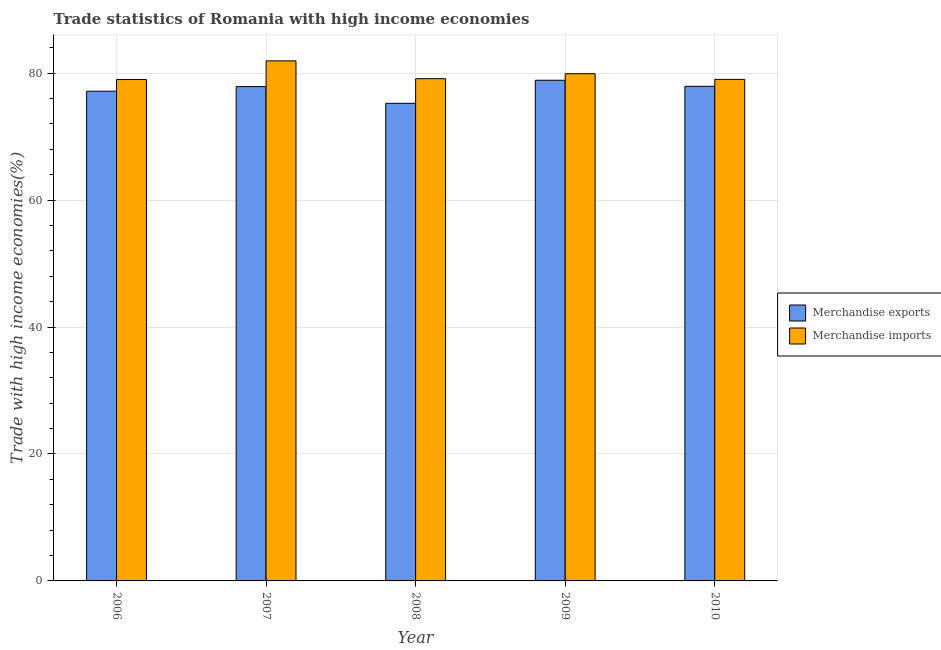How many different coloured bars are there?
Give a very brief answer. 2. Are the number of bars on each tick of the X-axis equal?
Keep it short and to the point. Yes. What is the merchandise imports in 2006?
Your answer should be compact. 79. Across all years, what is the maximum merchandise imports?
Make the answer very short. 81.93. Across all years, what is the minimum merchandise exports?
Make the answer very short. 75.24. In which year was the merchandise exports minimum?
Ensure brevity in your answer.  2008. What is the total merchandise imports in the graph?
Give a very brief answer. 398.97. What is the difference between the merchandise exports in 2008 and that in 2010?
Your answer should be very brief. -2.68. What is the difference between the merchandise exports in 2008 and the merchandise imports in 2007?
Your response must be concise. -2.63. What is the average merchandise exports per year?
Your answer should be compact. 77.41. What is the ratio of the merchandise exports in 2008 to that in 2010?
Offer a terse response. 0.97. Is the difference between the merchandise imports in 2008 and 2009 greater than the difference between the merchandise exports in 2008 and 2009?
Offer a terse response. No. What is the difference between the highest and the second highest merchandise exports?
Ensure brevity in your answer.  0.95. What is the difference between the highest and the lowest merchandise exports?
Your answer should be very brief. 3.63. Is the sum of the merchandise imports in 2006 and 2010 greater than the maximum merchandise exports across all years?
Offer a very short reply. Yes. What does the 2nd bar from the right in 2008 represents?
Make the answer very short. Merchandise exports. How many bars are there?
Offer a terse response. 10. Are all the bars in the graph horizontal?
Your response must be concise. No. What is the difference between two consecutive major ticks on the Y-axis?
Provide a succinct answer. 20. Are the values on the major ticks of Y-axis written in scientific E-notation?
Make the answer very short. No. Does the graph contain any zero values?
Your answer should be very brief. No. How are the legend labels stacked?
Your response must be concise. Vertical. What is the title of the graph?
Offer a very short reply. Trade statistics of Romania with high income economies. Does "Imports" appear as one of the legend labels in the graph?
Make the answer very short. No. What is the label or title of the Y-axis?
Make the answer very short. Trade with high income economies(%). What is the Trade with high income economies(%) in Merchandise exports in 2006?
Make the answer very short. 77.15. What is the Trade with high income economies(%) in Merchandise imports in 2006?
Your answer should be compact. 79. What is the Trade with high income economies(%) in Merchandise exports in 2007?
Your response must be concise. 77.88. What is the Trade with high income economies(%) of Merchandise imports in 2007?
Give a very brief answer. 81.93. What is the Trade with high income economies(%) in Merchandise exports in 2008?
Give a very brief answer. 75.24. What is the Trade with high income economies(%) of Merchandise imports in 2008?
Your answer should be compact. 79.12. What is the Trade with high income economies(%) in Merchandise exports in 2009?
Your response must be concise. 78.87. What is the Trade with high income economies(%) of Merchandise imports in 2009?
Provide a short and direct response. 79.91. What is the Trade with high income economies(%) in Merchandise exports in 2010?
Offer a very short reply. 77.92. What is the Trade with high income economies(%) of Merchandise imports in 2010?
Provide a short and direct response. 79.01. Across all years, what is the maximum Trade with high income economies(%) of Merchandise exports?
Provide a succinct answer. 78.87. Across all years, what is the maximum Trade with high income economies(%) in Merchandise imports?
Keep it short and to the point. 81.93. Across all years, what is the minimum Trade with high income economies(%) in Merchandise exports?
Your answer should be very brief. 75.24. Across all years, what is the minimum Trade with high income economies(%) of Merchandise imports?
Your response must be concise. 79. What is the total Trade with high income economies(%) in Merchandise exports in the graph?
Provide a succinct answer. 387.06. What is the total Trade with high income economies(%) of Merchandise imports in the graph?
Keep it short and to the point. 398.97. What is the difference between the Trade with high income economies(%) of Merchandise exports in 2006 and that in 2007?
Keep it short and to the point. -0.73. What is the difference between the Trade with high income economies(%) of Merchandise imports in 2006 and that in 2007?
Offer a very short reply. -2.93. What is the difference between the Trade with high income economies(%) in Merchandise exports in 2006 and that in 2008?
Offer a very short reply. 1.91. What is the difference between the Trade with high income economies(%) of Merchandise imports in 2006 and that in 2008?
Your answer should be very brief. -0.13. What is the difference between the Trade with high income economies(%) in Merchandise exports in 2006 and that in 2009?
Make the answer very short. -1.72. What is the difference between the Trade with high income economies(%) of Merchandise imports in 2006 and that in 2009?
Your answer should be very brief. -0.91. What is the difference between the Trade with high income economies(%) of Merchandise exports in 2006 and that in 2010?
Your answer should be very brief. -0.77. What is the difference between the Trade with high income economies(%) in Merchandise imports in 2006 and that in 2010?
Provide a succinct answer. -0.02. What is the difference between the Trade with high income economies(%) of Merchandise exports in 2007 and that in 2008?
Make the answer very short. 2.63. What is the difference between the Trade with high income economies(%) of Merchandise imports in 2007 and that in 2008?
Offer a terse response. 2.8. What is the difference between the Trade with high income economies(%) in Merchandise exports in 2007 and that in 2009?
Provide a succinct answer. -1. What is the difference between the Trade with high income economies(%) in Merchandise imports in 2007 and that in 2009?
Keep it short and to the point. 2.02. What is the difference between the Trade with high income economies(%) in Merchandise exports in 2007 and that in 2010?
Provide a succinct answer. -0.04. What is the difference between the Trade with high income economies(%) of Merchandise imports in 2007 and that in 2010?
Provide a succinct answer. 2.91. What is the difference between the Trade with high income economies(%) of Merchandise exports in 2008 and that in 2009?
Offer a very short reply. -3.63. What is the difference between the Trade with high income economies(%) of Merchandise imports in 2008 and that in 2009?
Make the answer very short. -0.78. What is the difference between the Trade with high income economies(%) in Merchandise exports in 2008 and that in 2010?
Provide a succinct answer. -2.68. What is the difference between the Trade with high income economies(%) in Merchandise imports in 2008 and that in 2010?
Make the answer very short. 0.11. What is the difference between the Trade with high income economies(%) in Merchandise exports in 2009 and that in 2010?
Offer a terse response. 0.95. What is the difference between the Trade with high income economies(%) in Merchandise imports in 2009 and that in 2010?
Your response must be concise. 0.89. What is the difference between the Trade with high income economies(%) of Merchandise exports in 2006 and the Trade with high income economies(%) of Merchandise imports in 2007?
Provide a short and direct response. -4.78. What is the difference between the Trade with high income economies(%) in Merchandise exports in 2006 and the Trade with high income economies(%) in Merchandise imports in 2008?
Your answer should be very brief. -1.97. What is the difference between the Trade with high income economies(%) of Merchandise exports in 2006 and the Trade with high income economies(%) of Merchandise imports in 2009?
Ensure brevity in your answer.  -2.76. What is the difference between the Trade with high income economies(%) in Merchandise exports in 2006 and the Trade with high income economies(%) in Merchandise imports in 2010?
Offer a very short reply. -1.86. What is the difference between the Trade with high income economies(%) of Merchandise exports in 2007 and the Trade with high income economies(%) of Merchandise imports in 2008?
Offer a terse response. -1.25. What is the difference between the Trade with high income economies(%) in Merchandise exports in 2007 and the Trade with high income economies(%) in Merchandise imports in 2009?
Your response must be concise. -2.03. What is the difference between the Trade with high income economies(%) in Merchandise exports in 2007 and the Trade with high income economies(%) in Merchandise imports in 2010?
Provide a succinct answer. -1.14. What is the difference between the Trade with high income economies(%) of Merchandise exports in 2008 and the Trade with high income economies(%) of Merchandise imports in 2009?
Provide a short and direct response. -4.66. What is the difference between the Trade with high income economies(%) of Merchandise exports in 2008 and the Trade with high income economies(%) of Merchandise imports in 2010?
Make the answer very short. -3.77. What is the difference between the Trade with high income economies(%) in Merchandise exports in 2009 and the Trade with high income economies(%) in Merchandise imports in 2010?
Give a very brief answer. -0.14. What is the average Trade with high income economies(%) in Merchandise exports per year?
Make the answer very short. 77.41. What is the average Trade with high income economies(%) of Merchandise imports per year?
Provide a succinct answer. 79.79. In the year 2006, what is the difference between the Trade with high income economies(%) in Merchandise exports and Trade with high income economies(%) in Merchandise imports?
Give a very brief answer. -1.85. In the year 2007, what is the difference between the Trade with high income economies(%) of Merchandise exports and Trade with high income economies(%) of Merchandise imports?
Make the answer very short. -4.05. In the year 2008, what is the difference between the Trade with high income economies(%) of Merchandise exports and Trade with high income economies(%) of Merchandise imports?
Your response must be concise. -3.88. In the year 2009, what is the difference between the Trade with high income economies(%) of Merchandise exports and Trade with high income economies(%) of Merchandise imports?
Provide a succinct answer. -1.03. In the year 2010, what is the difference between the Trade with high income economies(%) of Merchandise exports and Trade with high income economies(%) of Merchandise imports?
Give a very brief answer. -1.09. What is the ratio of the Trade with high income economies(%) of Merchandise imports in 2006 to that in 2007?
Keep it short and to the point. 0.96. What is the ratio of the Trade with high income economies(%) of Merchandise exports in 2006 to that in 2008?
Your response must be concise. 1.03. What is the ratio of the Trade with high income economies(%) in Merchandise imports in 2006 to that in 2008?
Make the answer very short. 1. What is the ratio of the Trade with high income economies(%) of Merchandise exports in 2006 to that in 2009?
Make the answer very short. 0.98. What is the ratio of the Trade with high income economies(%) of Merchandise imports in 2006 to that in 2009?
Your answer should be compact. 0.99. What is the ratio of the Trade with high income economies(%) of Merchandise exports in 2007 to that in 2008?
Your response must be concise. 1.03. What is the ratio of the Trade with high income economies(%) in Merchandise imports in 2007 to that in 2008?
Offer a terse response. 1.04. What is the ratio of the Trade with high income economies(%) in Merchandise exports in 2007 to that in 2009?
Offer a very short reply. 0.99. What is the ratio of the Trade with high income economies(%) of Merchandise imports in 2007 to that in 2009?
Give a very brief answer. 1.03. What is the ratio of the Trade with high income economies(%) of Merchandise exports in 2007 to that in 2010?
Ensure brevity in your answer.  1. What is the ratio of the Trade with high income economies(%) in Merchandise imports in 2007 to that in 2010?
Your response must be concise. 1.04. What is the ratio of the Trade with high income economies(%) of Merchandise exports in 2008 to that in 2009?
Provide a succinct answer. 0.95. What is the ratio of the Trade with high income economies(%) of Merchandise imports in 2008 to that in 2009?
Offer a terse response. 0.99. What is the ratio of the Trade with high income economies(%) in Merchandise exports in 2008 to that in 2010?
Your answer should be compact. 0.97. What is the ratio of the Trade with high income economies(%) in Merchandise exports in 2009 to that in 2010?
Make the answer very short. 1.01. What is the ratio of the Trade with high income economies(%) in Merchandise imports in 2009 to that in 2010?
Your response must be concise. 1.01. What is the difference between the highest and the second highest Trade with high income economies(%) in Merchandise exports?
Your response must be concise. 0.95. What is the difference between the highest and the second highest Trade with high income economies(%) in Merchandise imports?
Provide a short and direct response. 2.02. What is the difference between the highest and the lowest Trade with high income economies(%) of Merchandise exports?
Your response must be concise. 3.63. What is the difference between the highest and the lowest Trade with high income economies(%) in Merchandise imports?
Provide a succinct answer. 2.93. 